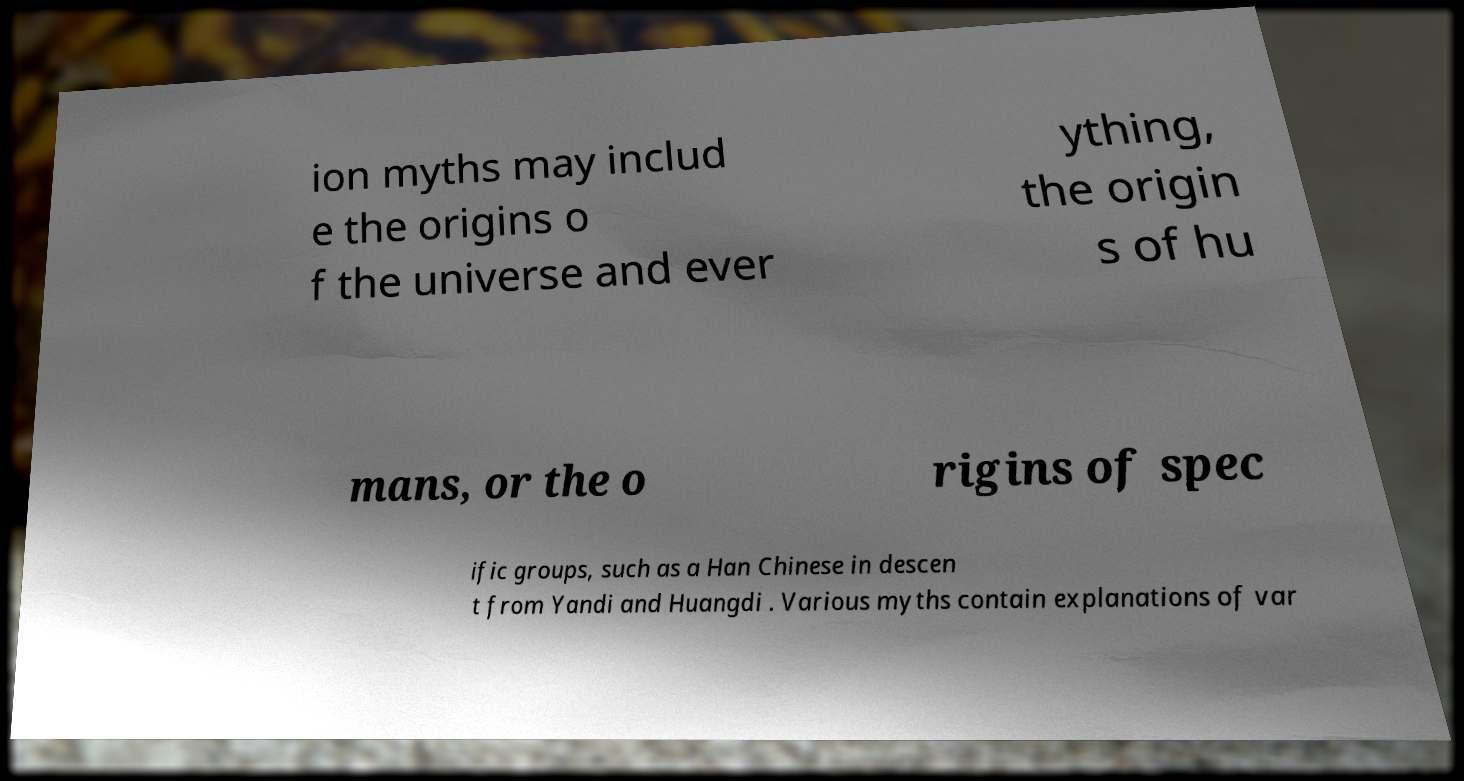Can you accurately transcribe the text from the provided image for me? ion myths may includ e the origins o f the universe and ever ything, the origin s of hu mans, or the o rigins of spec ific groups, such as a Han Chinese in descen t from Yandi and Huangdi . Various myths contain explanations of var 